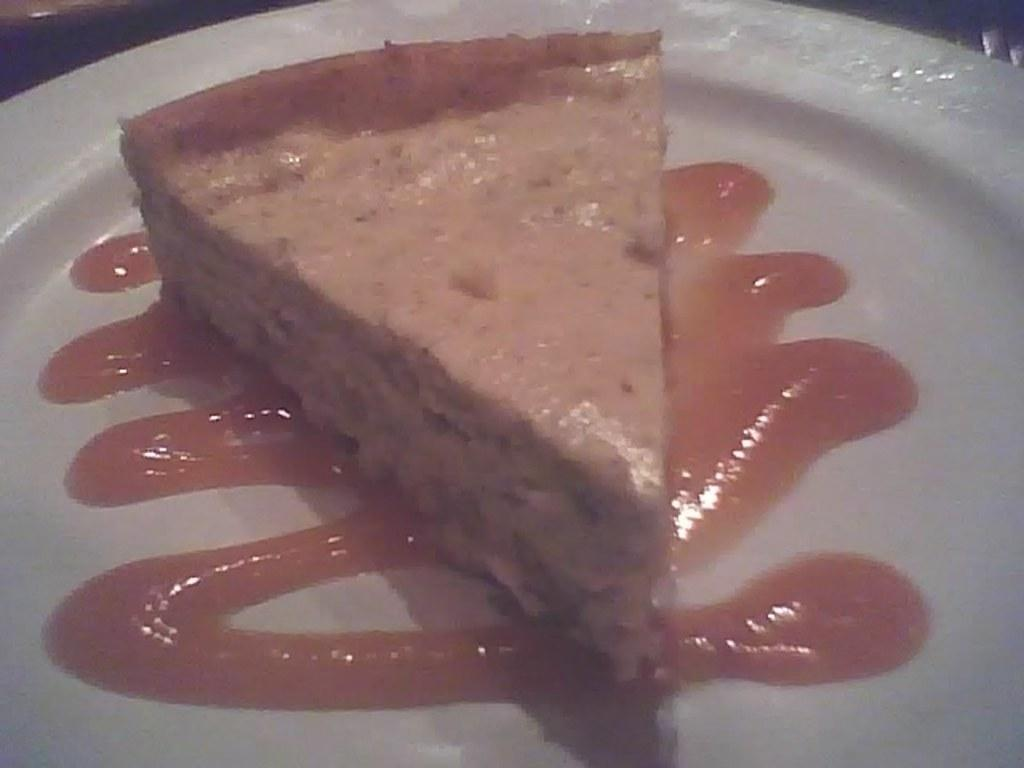What can be seen on the plate in the image? There is a food item on the plate in the image. What is the color of the plate? The plate is white in color. Can you describe the sauce on the food item? There is a sauce on the food item, but its specific appearance or flavor cannot be determined from the image. What is the brother teaching during the holiday in the image? There is no reference to a brother, teaching, or holiday in the image, so it is not possible to answer that question. 